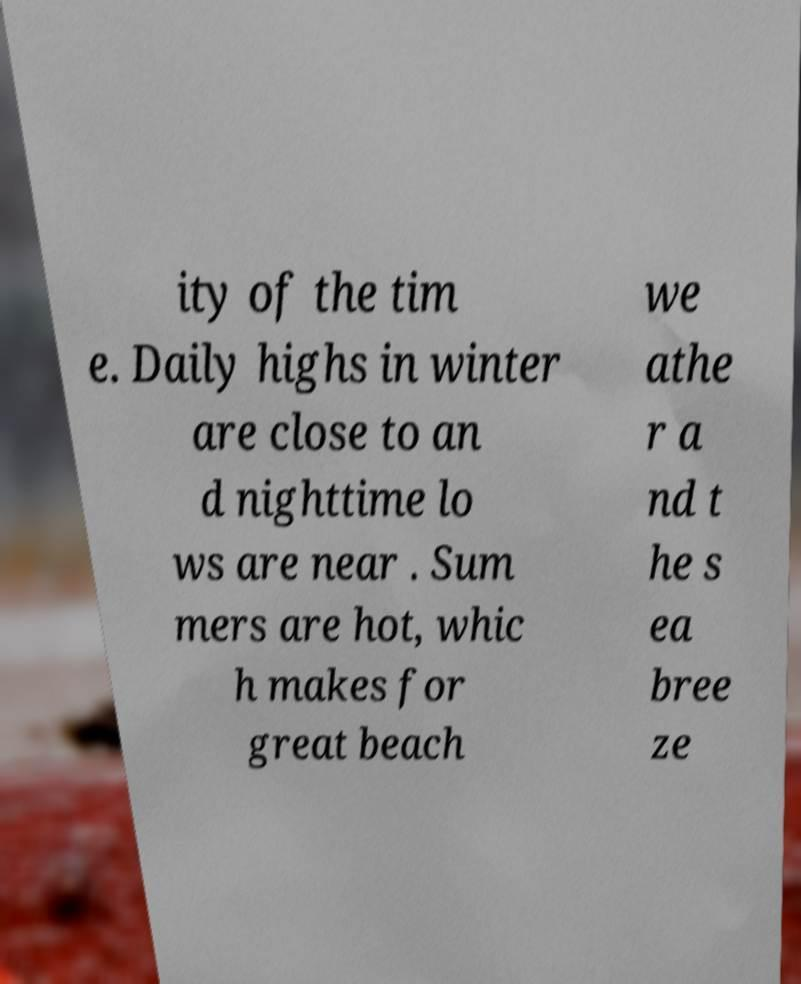What messages or text are displayed in this image? I need them in a readable, typed format. ity of the tim e. Daily highs in winter are close to an d nighttime lo ws are near . Sum mers are hot, whic h makes for great beach we athe r a nd t he s ea bree ze 